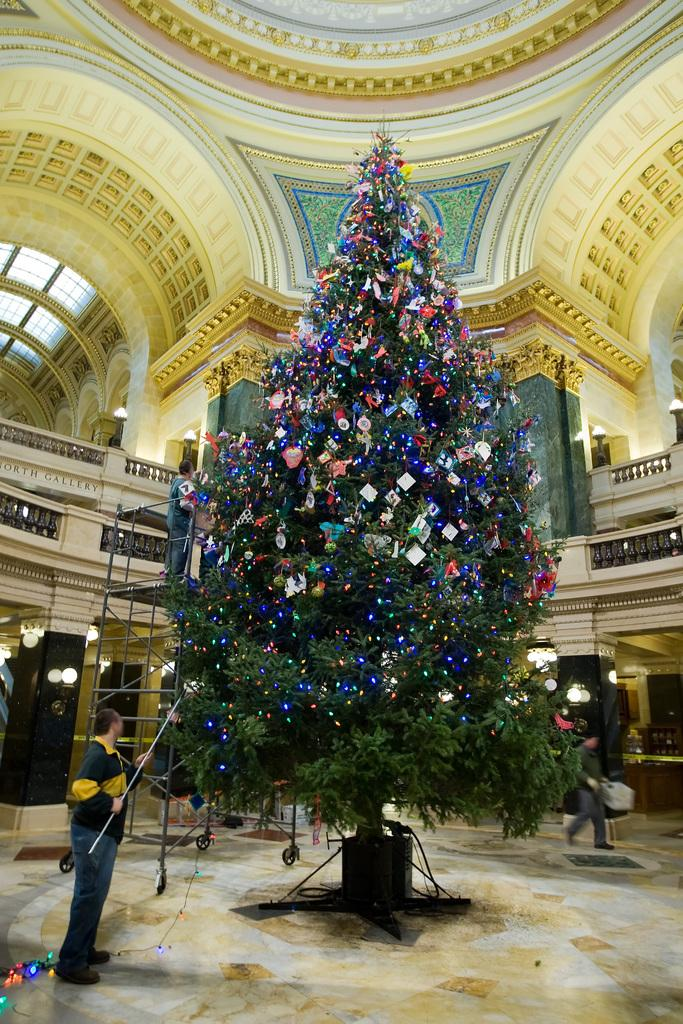What is the man in the image doing? The man is standing in the image and holding a stick. What object is associated with the holiday season in the image? There is a Christmas tree in the image. Can you describe the background of the image? There is a person, a wall, and lights in the background of the image. What type of glove is the man wearing in the image? The man is not wearing a glove in the image. What toys can be seen on the floor in the image? There are no toys visible on the floor in the image. 